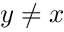Convert formula to latex. <formula><loc_0><loc_0><loc_500><loc_500>y \ne x</formula> 